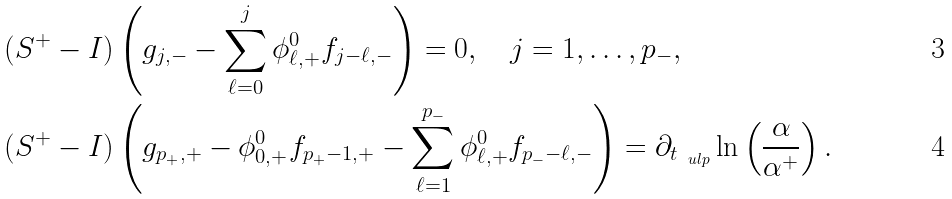Convert formula to latex. <formula><loc_0><loc_0><loc_500><loc_500>& ( S ^ { + } - I ) \left ( g _ { j , - } - \sum _ { \ell = 0 } ^ { j } \phi _ { \ell , + } ^ { 0 } f _ { j - \ell , - } \right ) = 0 , \quad j = 1 , \dots , p _ { - } , \\ & ( S ^ { + } - I ) \left ( g _ { p _ { + } , + } - \phi _ { 0 , + } ^ { 0 } f _ { p _ { + } - 1 , + } - \sum _ { \ell = 1 } ^ { p _ { - } } \phi _ { \ell , + } ^ { 0 } f _ { p _ { - } - \ell , - } \right ) = \partial _ { t _ { \ u l p } } \ln \left ( \frac { \alpha } { \alpha ^ { + } } \right ) .</formula> 